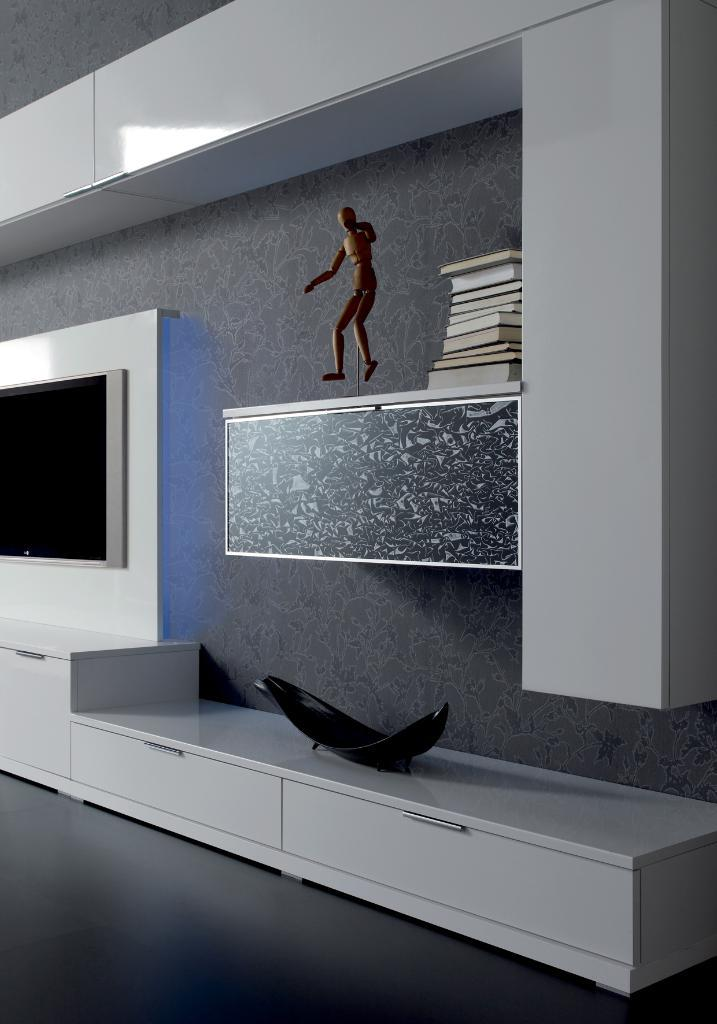What electronic device is visible in the image? There is a television in the image. Where is the toy located in the image? The toy is on a shelf in the image. What type of items can be seen besides the television and toy? There are books and drawers in the image. What decorative object is present in the image? There is a showpiece in the image. What type of silk fabric is draped over the television in the image? There is no silk fabric draped over the television in the image. What arithmetic problem is being solved on the showpiece in the image? There is no arithmetic problem being solved on the showpiece in the image. 